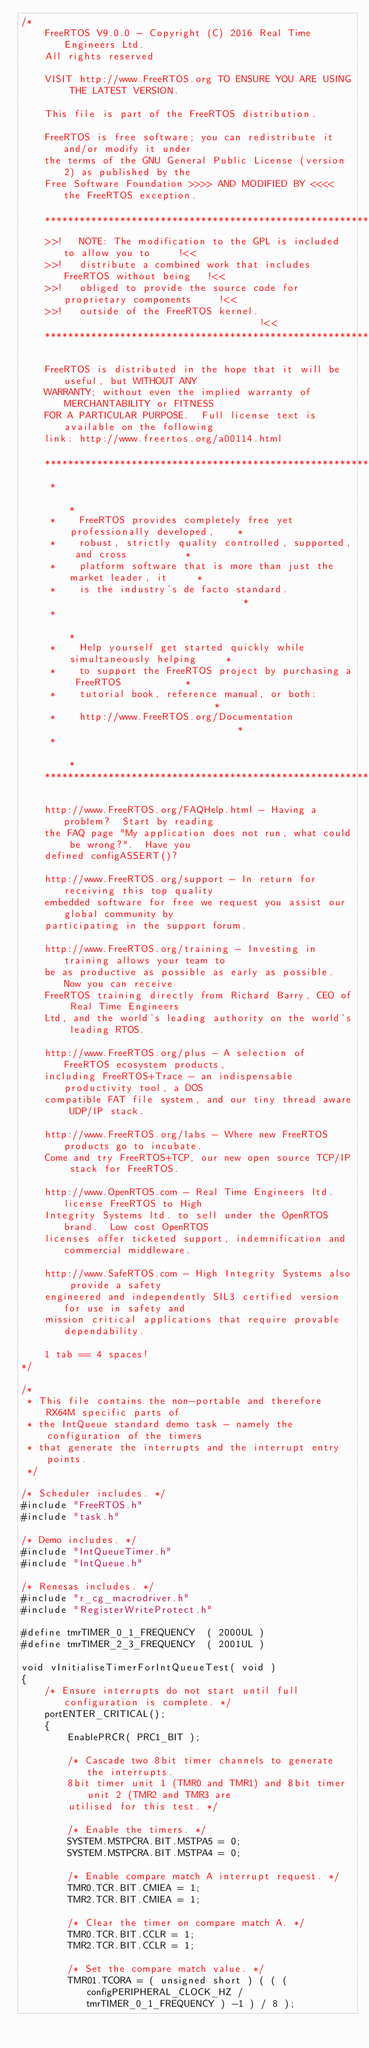<code> <loc_0><loc_0><loc_500><loc_500><_C_>/*
    FreeRTOS V9.0.0 - Copyright (C) 2016 Real Time Engineers Ltd.
    All rights reserved

    VISIT http://www.FreeRTOS.org TO ENSURE YOU ARE USING THE LATEST VERSION.

    This file is part of the FreeRTOS distribution.

    FreeRTOS is free software; you can redistribute it and/or modify it under
    the terms of the GNU General Public License (version 2) as published by the
    Free Software Foundation >>>> AND MODIFIED BY <<<< the FreeRTOS exception.

    ***************************************************************************
    >>!   NOTE: The modification to the GPL is included to allow you to     !<<
    >>!   distribute a combined work that includes FreeRTOS without being   !<<
    >>!   obliged to provide the source code for proprietary components     !<<
    >>!   outside of the FreeRTOS kernel.                                   !<<
    ***************************************************************************

    FreeRTOS is distributed in the hope that it will be useful, but WITHOUT ANY
    WARRANTY; without even the implied warranty of MERCHANTABILITY or FITNESS
    FOR A PARTICULAR PURPOSE.  Full license text is available on the following
    link: http://www.freertos.org/a00114.html

    ***************************************************************************
     *                                                                       *
     *    FreeRTOS provides completely free yet professionally developed,    *
     *    robust, strictly quality controlled, supported, and cross          *
     *    platform software that is more than just the market leader, it     *
     *    is the industry's de facto standard.                               *
     *                                                                       *
     *    Help yourself get started quickly while simultaneously helping     *
     *    to support the FreeRTOS project by purchasing a FreeRTOS           *
     *    tutorial book, reference manual, or both:                          *
     *    http://www.FreeRTOS.org/Documentation                              *
     *                                                                       *
    ***************************************************************************

    http://www.FreeRTOS.org/FAQHelp.html - Having a problem?  Start by reading
    the FAQ page "My application does not run, what could be wrong?".  Have you
    defined configASSERT()?

    http://www.FreeRTOS.org/support - In return for receiving this top quality
    embedded software for free we request you assist our global community by
    participating in the support forum.

    http://www.FreeRTOS.org/training - Investing in training allows your team to
    be as productive as possible as early as possible.  Now you can receive
    FreeRTOS training directly from Richard Barry, CEO of Real Time Engineers
    Ltd, and the world's leading authority on the world's leading RTOS.

    http://www.FreeRTOS.org/plus - A selection of FreeRTOS ecosystem products,
    including FreeRTOS+Trace - an indispensable productivity tool, a DOS
    compatible FAT file system, and our tiny thread aware UDP/IP stack.

    http://www.FreeRTOS.org/labs - Where new FreeRTOS products go to incubate.
    Come and try FreeRTOS+TCP, our new open source TCP/IP stack for FreeRTOS.

    http://www.OpenRTOS.com - Real Time Engineers ltd. license FreeRTOS to High
    Integrity Systems ltd. to sell under the OpenRTOS brand.  Low cost OpenRTOS
    licenses offer ticketed support, indemnification and commercial middleware.

    http://www.SafeRTOS.com - High Integrity Systems also provide a safety
    engineered and independently SIL3 certified version for use in safety and
    mission critical applications that require provable dependability.

    1 tab == 4 spaces!
*/

/*
 * This file contains the non-portable and therefore RX64M specific parts of
 * the IntQueue standard demo task - namely the configuration of the timers
 * that generate the interrupts and the interrupt entry points.
 */

/* Scheduler includes. */
#include "FreeRTOS.h"
#include "task.h"

/* Demo includes. */
#include "IntQueueTimer.h"
#include "IntQueue.h"

/* Renesas includes. */
#include "r_cg_macrodriver.h"
#include "RegisterWriteProtect.h"

#define tmrTIMER_0_1_FREQUENCY	( 2000UL )
#define tmrTIMER_2_3_FREQUENCY	( 2001UL )

void vInitialiseTimerForIntQueueTest( void )
{
	/* Ensure interrupts do not start until full configuration is complete. */
	portENTER_CRITICAL();
	{
		EnablePRCR( PRC1_BIT );

		/* Cascade two 8bit timer channels to generate the interrupts. 
		8bit timer unit 1 (TMR0 and TMR1) and 8bit timer unit 2 (TMR2 and TMR3 are
		utilised for this test. */

		/* Enable the timers. */
		SYSTEM.MSTPCRA.BIT.MSTPA5 = 0;
		SYSTEM.MSTPCRA.BIT.MSTPA4 = 0;

		/* Enable compare match A interrupt request. */
		TMR0.TCR.BIT.CMIEA = 1;
		TMR2.TCR.BIT.CMIEA = 1;

		/* Clear the timer on compare match A. */
		TMR0.TCR.BIT.CCLR = 1;
		TMR2.TCR.BIT.CCLR = 1;

		/* Set the compare match value. */
		TMR01.TCORA = ( unsigned short ) ( ( ( configPERIPHERAL_CLOCK_HZ / tmrTIMER_0_1_FREQUENCY ) -1 ) / 8 );</code> 